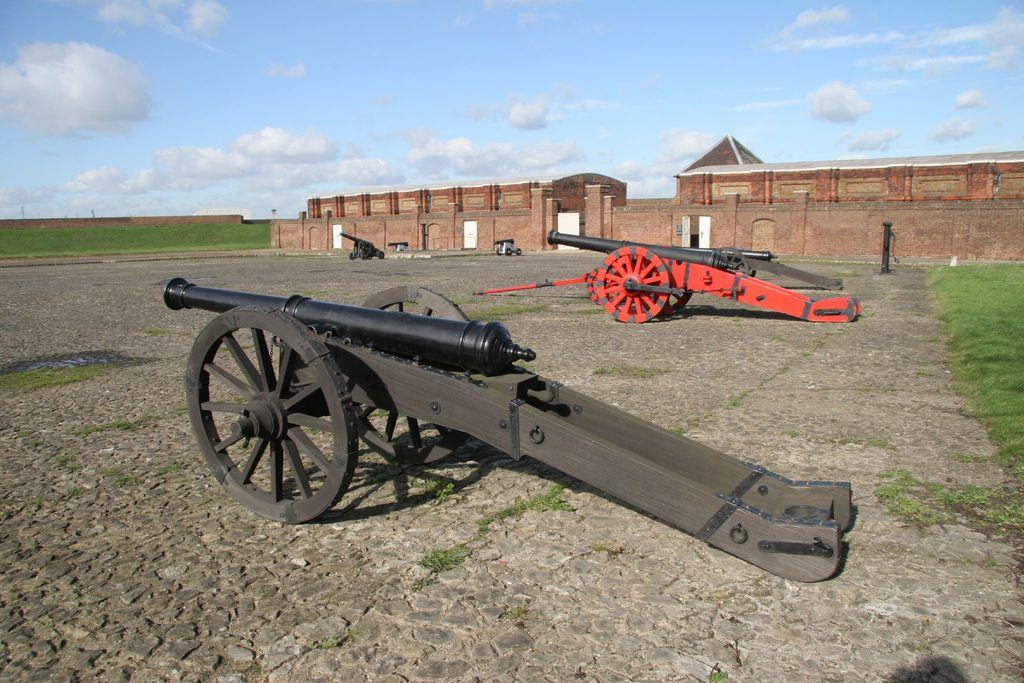What is located in the foreground of the picture? There are cannons on cobblestone and a fort in the foreground of the picture. What is the main structure in the foreground? The main structure in the foreground is a fort. What can be seen on the left side of the picture? There is a fort wall on the left side of the picture. How would you describe the sky in the picture? The sky is partly cloudy, and the weather is sunny. How many apples are hanging from the fort wall in the picture? There are no apples present in the image; the focus is on the cannons, fort, and fort wall. What type of design is featured on the cannons in the picture? The provided facts do not mention any specific design on the cannons, so we cannot answer this question definitively. 